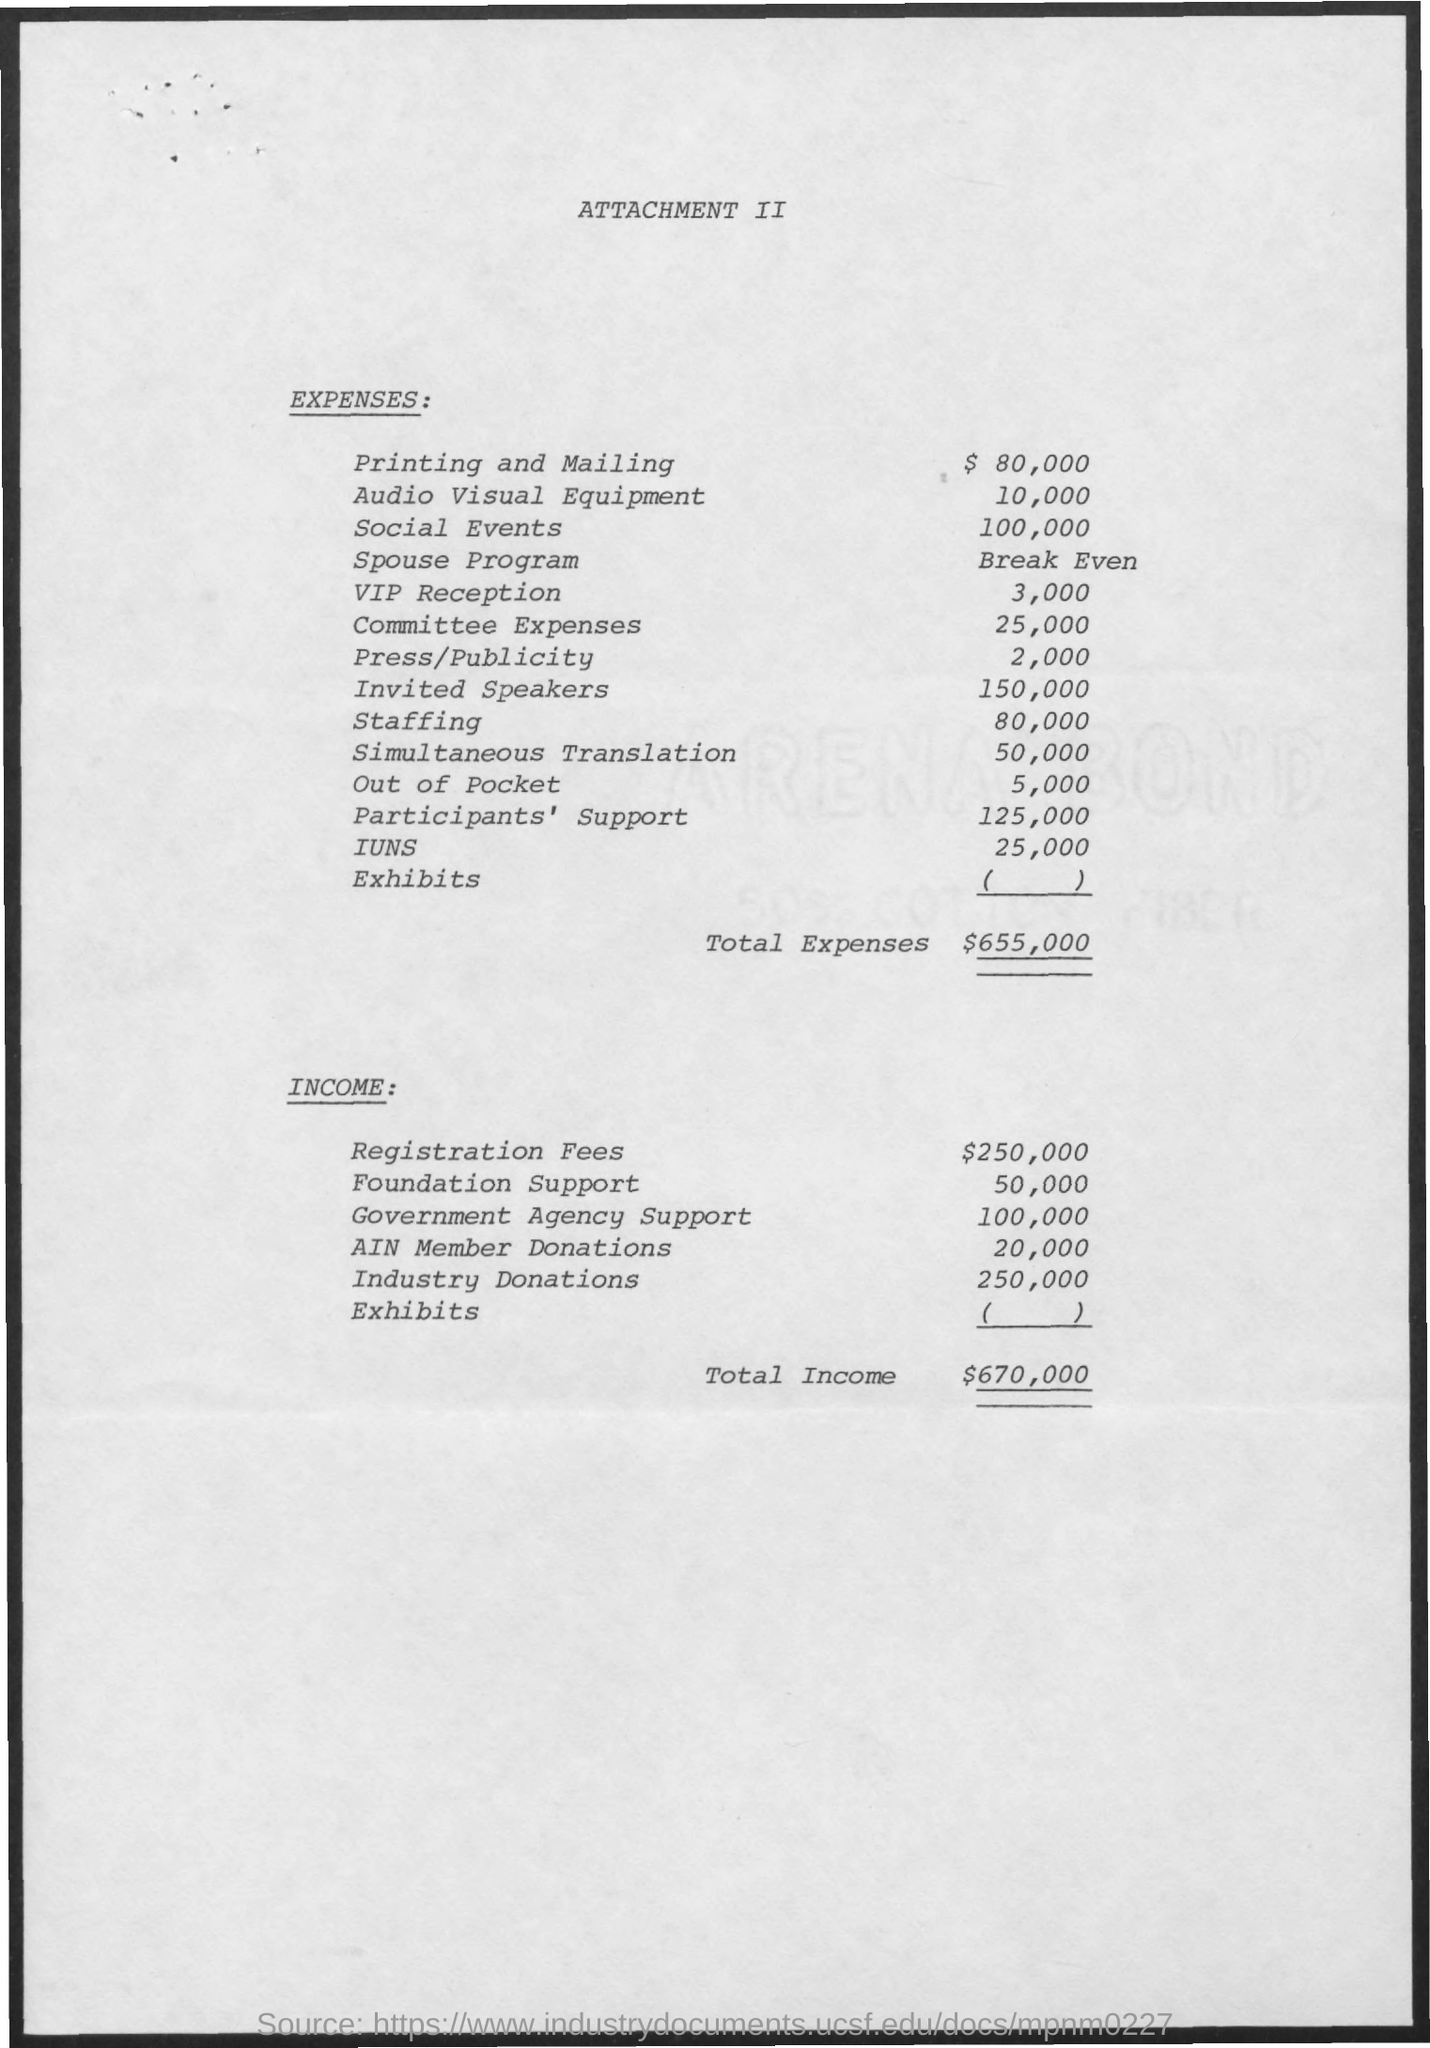What are the Expenses for Printing and Mailing?
Offer a very short reply. $ 80,000. What are the Expenses for Audio Visual Equipment?
Provide a short and direct response. 10,000. What are the Expenses for Social Events?
Offer a terse response. 100,000. What are the Expenses for Spouse Program?
Offer a terse response. Break Even. What are the Expenses for VIP Reception?
Your response must be concise. 3,000. What are the Expenses for Committee Expenses?
Ensure brevity in your answer.  25,000. What are the Expenses for Press/Publicity?
Offer a terse response. 2,000. What are the Expenses for Invited Speakers?
Provide a succinct answer. 150,000. What are the Expenses for Staffing?
Ensure brevity in your answer.  80,000. Which is the most expensive in the list of Expenses in this document?
Provide a succinct answer. Invited Speakers. 